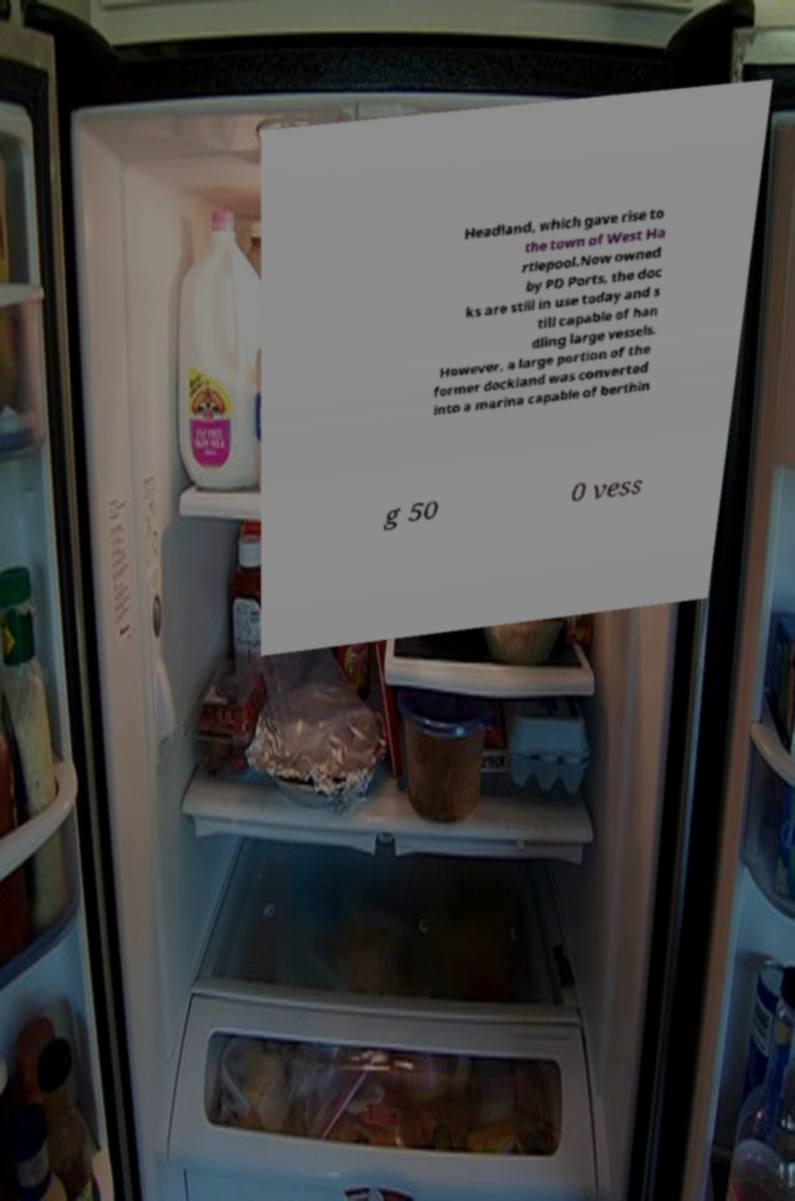Could you extract and type out the text from this image? Headland, which gave rise to the town of West Ha rtlepool.Now owned by PD Ports, the doc ks are still in use today and s till capable of han dling large vessels. However, a large portion of the former dockland was converted into a marina capable of berthin g 50 0 vess 